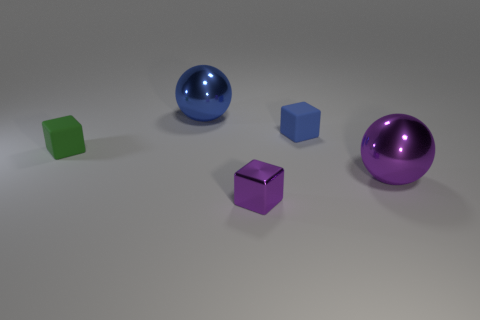Subtract all green matte cubes. How many cubes are left? 2 Subtract all purple balls. How many balls are left? 1 Subtract 1 blocks. How many blocks are left? 2 Add 2 green metallic things. How many objects exist? 7 Subtract all cubes. How many objects are left? 2 Subtract all red spheres. Subtract all brown blocks. How many spheres are left? 2 Subtract all big rubber things. Subtract all big purple balls. How many objects are left? 4 Add 2 large balls. How many large balls are left? 4 Add 1 large purple things. How many large purple things exist? 2 Subtract 0 blue cylinders. How many objects are left? 5 